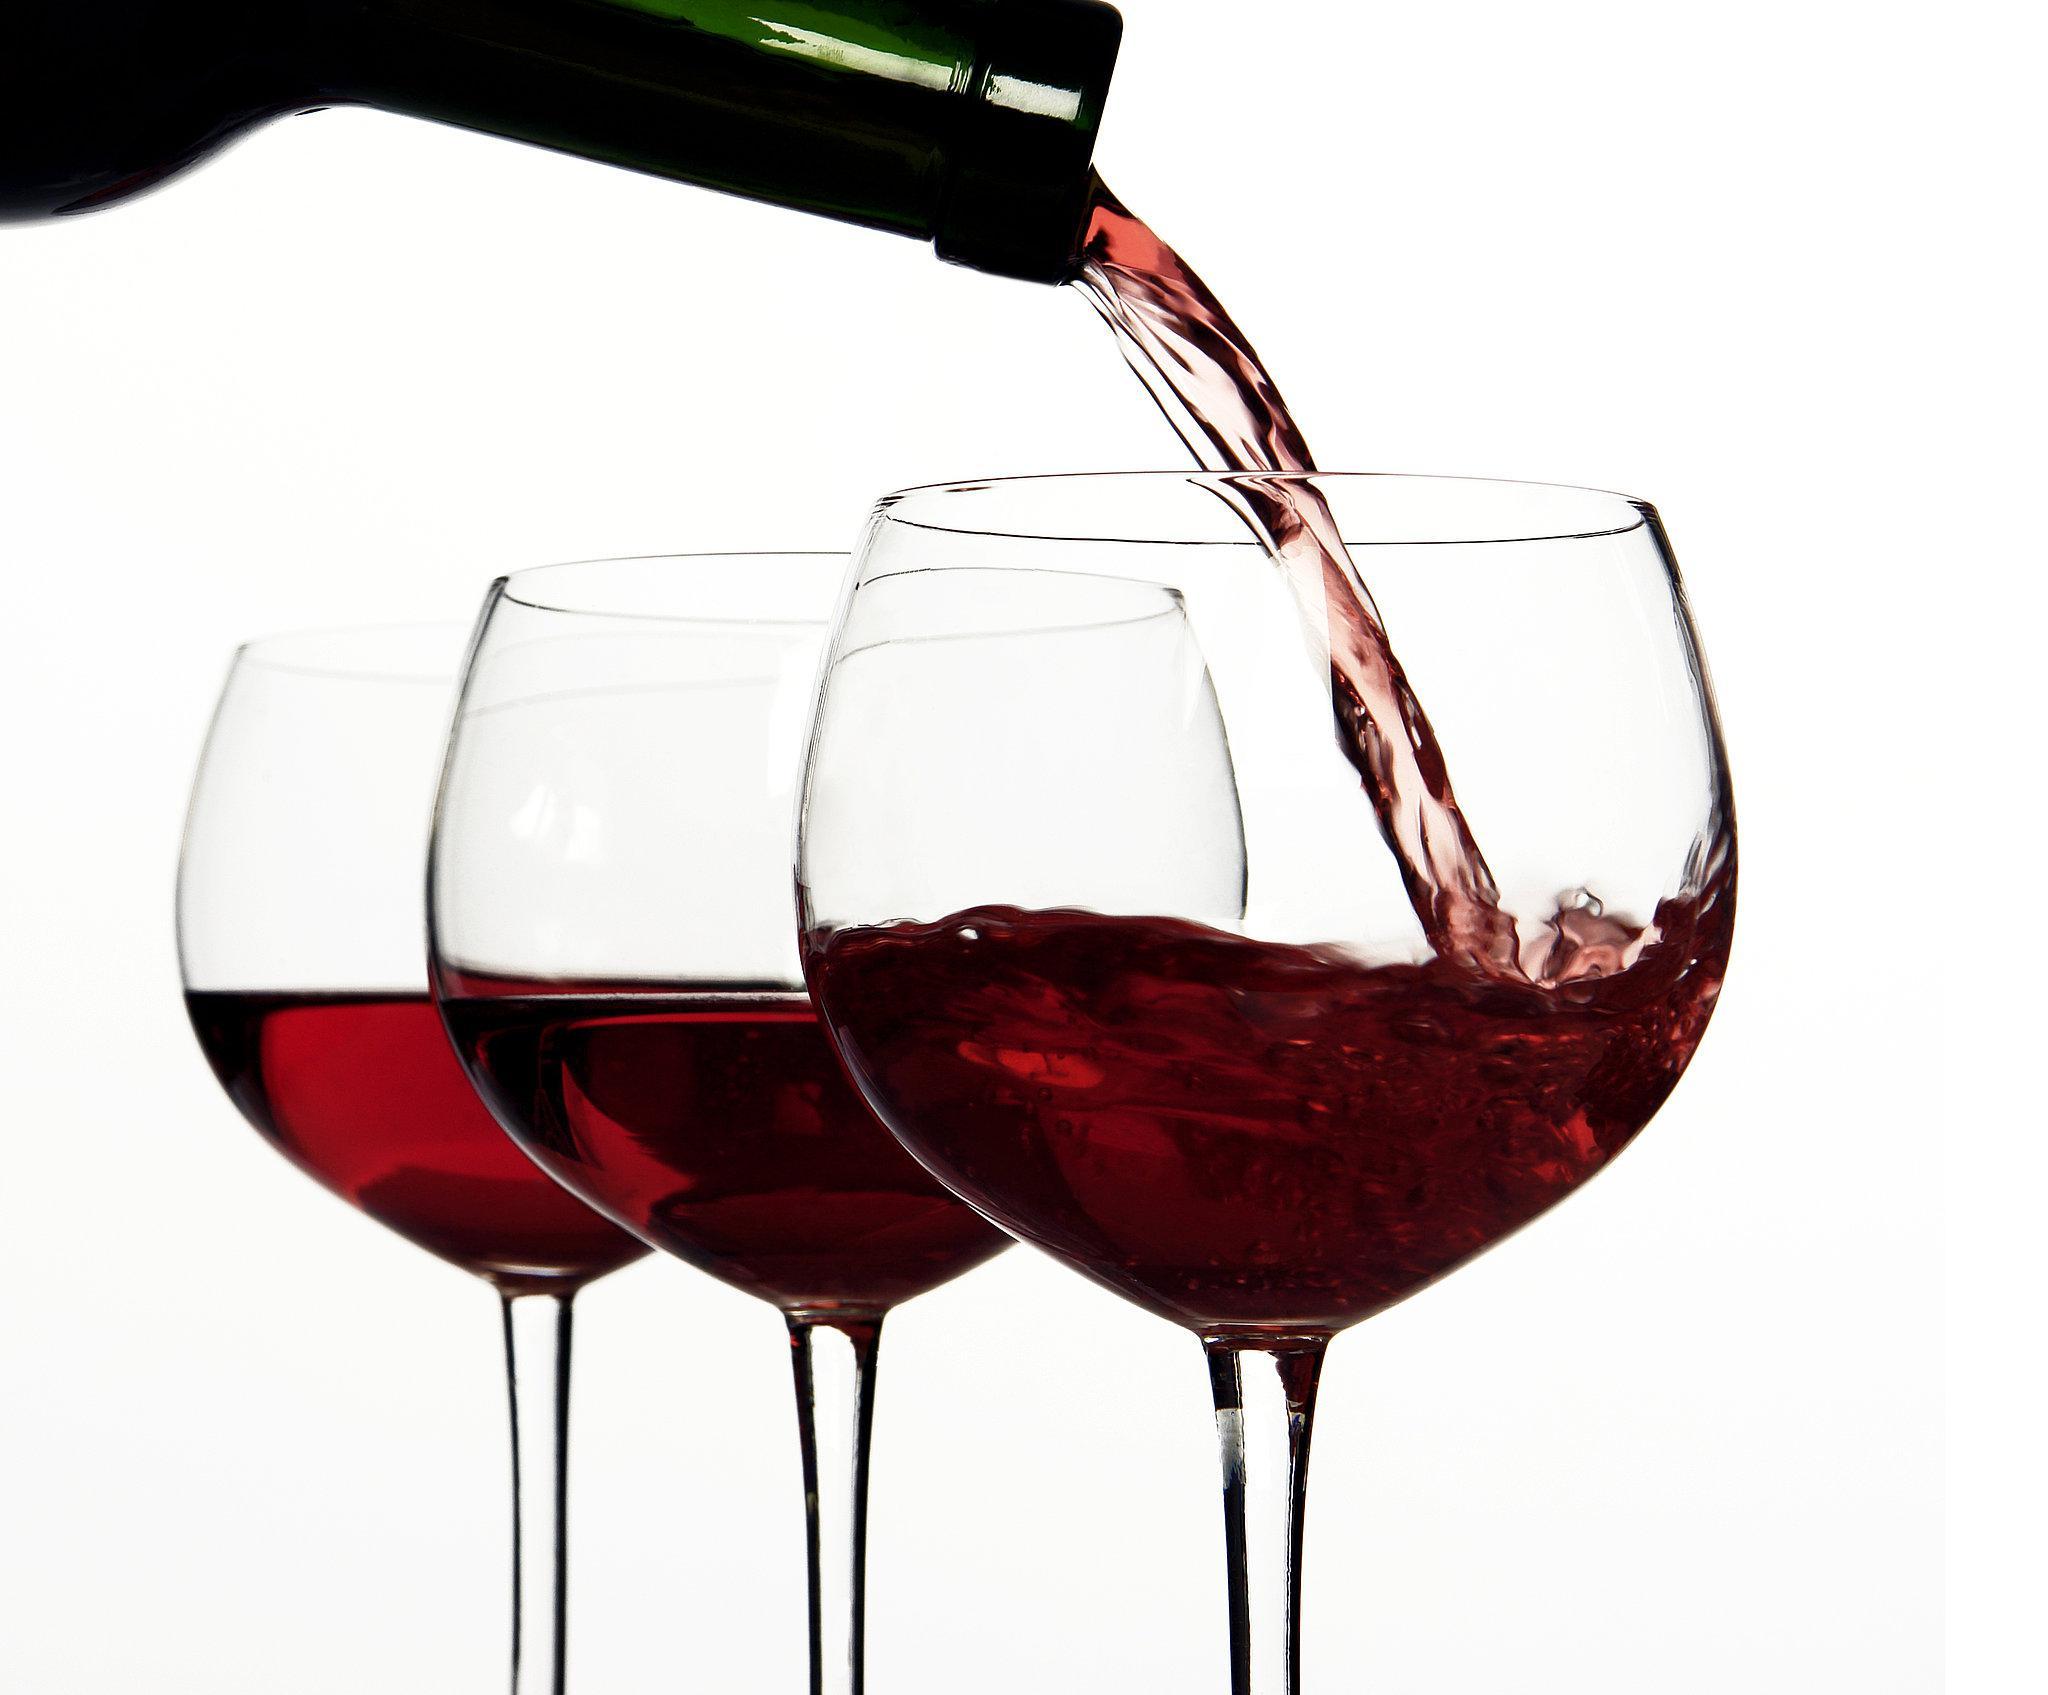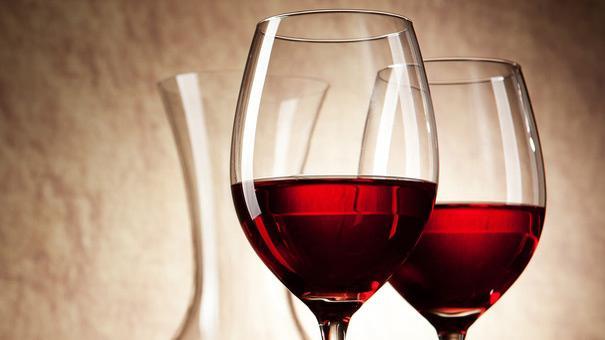The first image is the image on the left, the second image is the image on the right. Assess this claim about the two images: "One of the images contains exactly two glasses of wine.". Correct or not? Answer yes or no. Yes. 